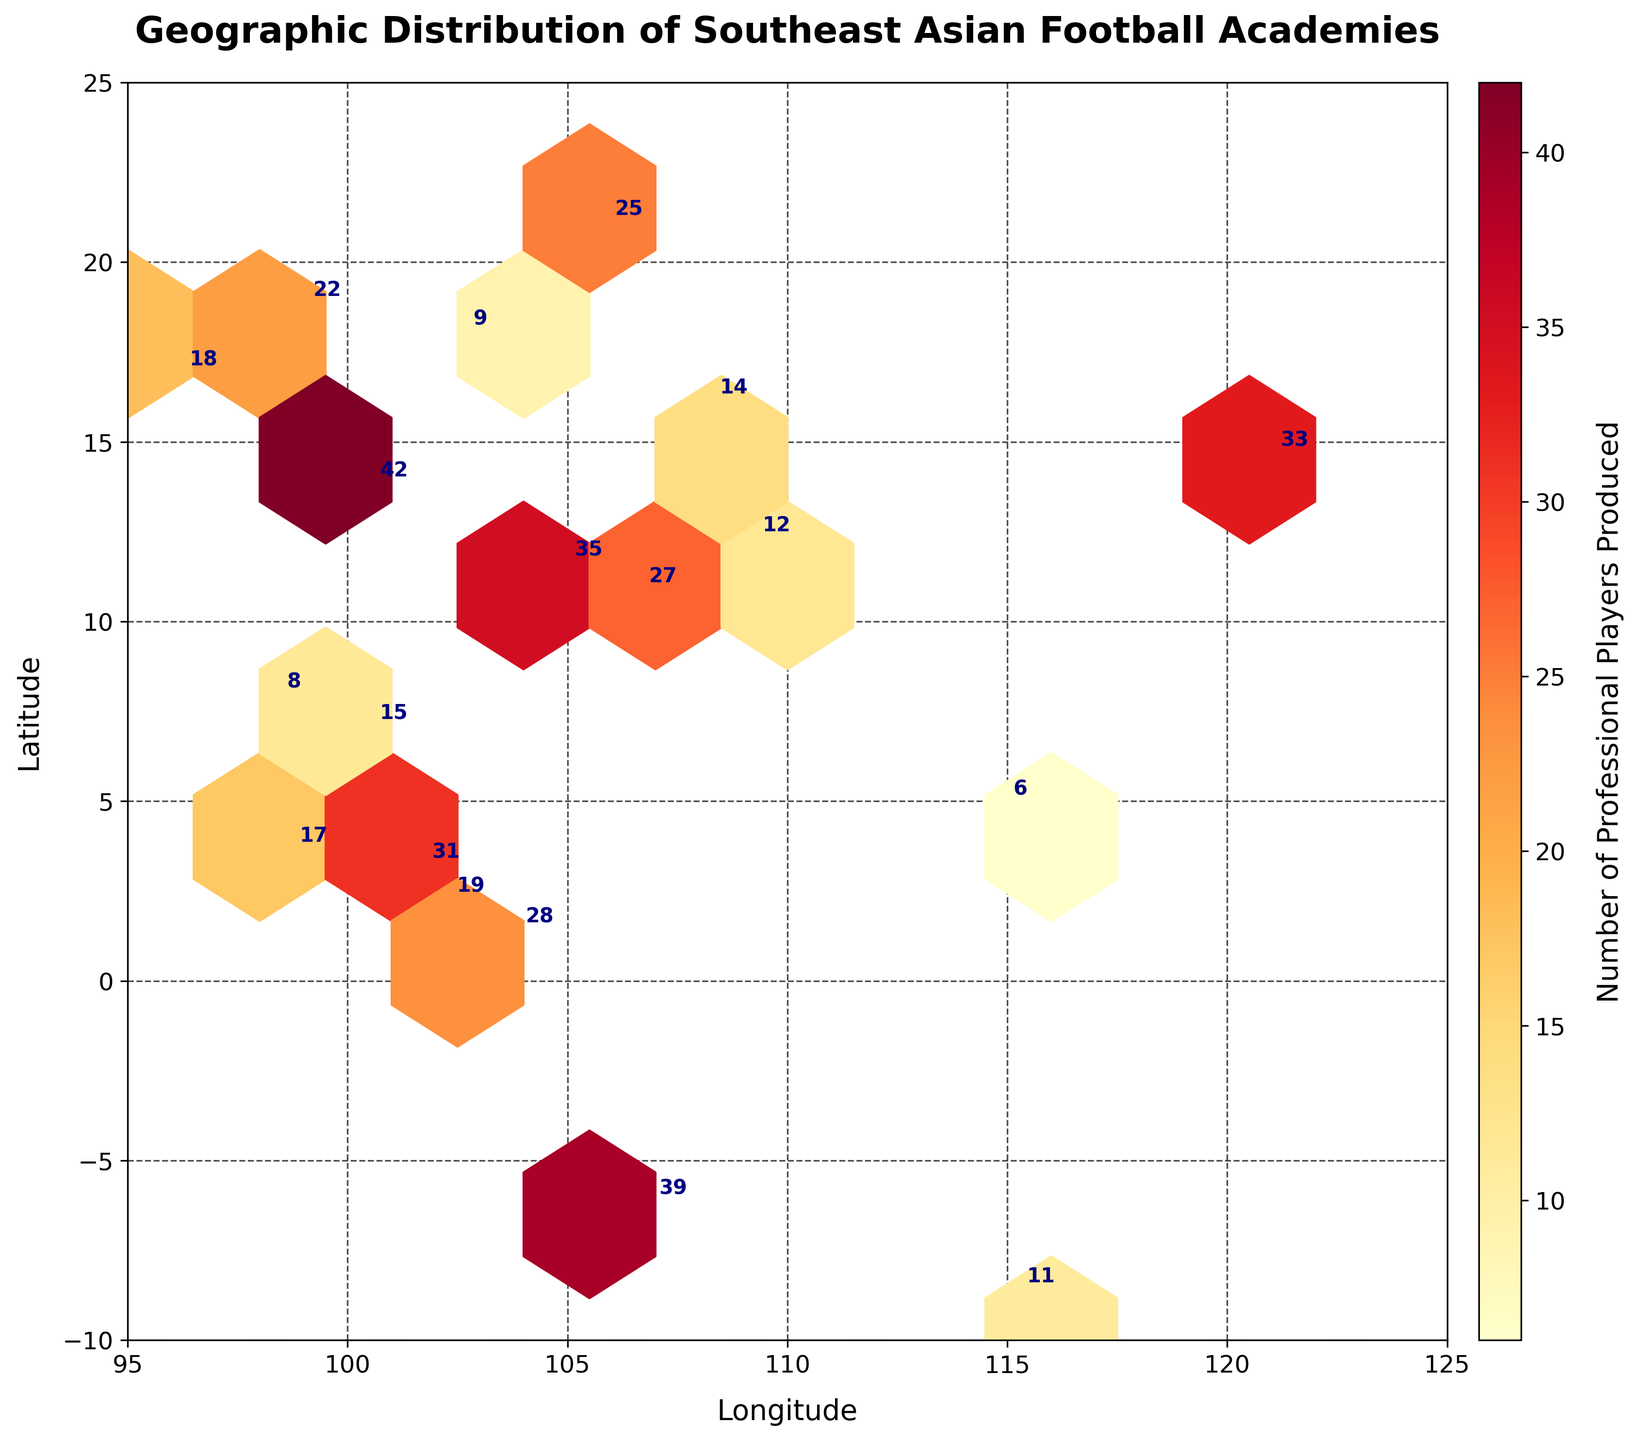what is the title of the figure? The title of the figure is typically found at the top, clearly labeled in bold text.
Answer: Geographic Distribution of Southeast Asian Football Academies Which city has produced the highest number of professional players? By examining the plot, observe which labeled city has the highest number next to its marker.
Answer: Bangkok (42) How many football academies are represented in the plot? Count the number of distinct markers on the plot; each represents a football academy.
Answer: 20 Which country appears to have the most evenly distributed number of players produced across its academies? Look for a country where the numbers next to its cities are close to each other, without extreme variations.
Answer: Vietnam (Hanoi: 25, Ho Chi Minh City: 27, Nha Trang: 12, Da Nang: 14) What is the average number of professional players produced by the academies in Malaysia? Add the numbers for the Malaysian cities and divide by the number of cities.
Answer: (31 + 17 + 19) / 3 = 22.33 Which regions have no representation on the plot? Identify areas within the plot's axis limits where there are no markers.
Answer: Regions east of 115 longitude and south of 6 latitude Between Jakarta and Phnom Penh, which football academy has produced more professional players? Compare the numbers next to Jakarta and Phnom Penh markers.
Answer: Jakarta (39) Which city in Vietnam has the lowest number of professional players produced? Look at all the cities in Vietnam and identify the one with the smallest number.
Answer: Nha Trang (12) How does the distribution of players produced in Southeast Asia relate to longitude? Observe the spread of markers along the x-axis (longitude). Determine if higher numbers are concentrated in certain longitudes.
Answer: Higher concentration of players produced is seen around 100 to 106 longitude What color represents the highest density of professional players produced on the hexbin plot? Observe the color bar that indicates the density of players.
Answer: Dark Red 